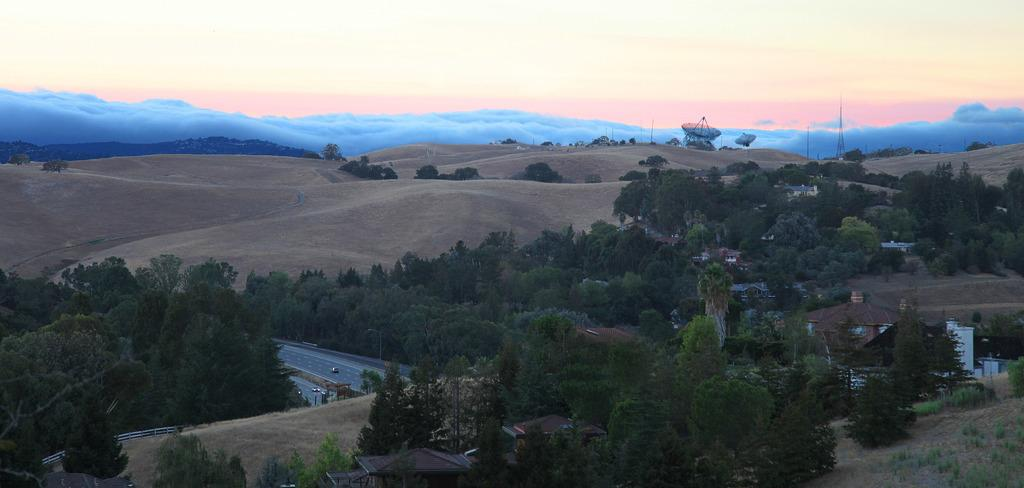What type of natural elements can be seen in the image? There are trees in the image. What type of man-made structures are present in the image? There are houses, poles, a fence, and antennas in the image. What type of transportation is visible in the image? There are vehicles on the road in the image. What type of geographical feature is visible behind the trees? There are hills behind the trees in the image. What part of the natural environment is visible in the image? The sky is visible in the image. What type of crown is the tree wearing in the image? There is no crown present in the image; it is a tree in its natural state. What type of engine is powering the hills in the image? There is no engine present in the image; the hills are a natural geographical feature. 